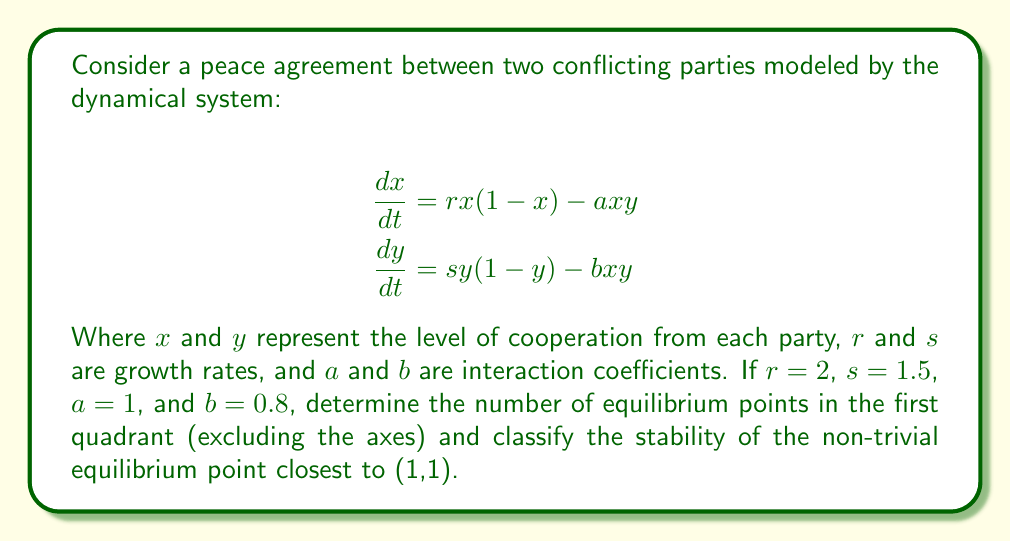Teach me how to tackle this problem. To solve this problem, we'll follow these steps:

1) Find the equilibrium points by setting $\frac{dx}{dt} = 0$ and $\frac{dy}{dt} = 0$:

   $$2x(1-x) - xy = 0$$
   $$1.5y(1-y) - 0.8xy = 0$$

2) Solve these equations:
   From the first equation:
   $$x(2-2x-y) = 0$$
   So either $x=0$ or $2-2x-y=0$

   From the second equation:
   $$y(1.5-1.5y-0.8x) = 0$$
   So either $y=0$ or $1.5-1.5y-0.8x=0$

3) The equilibrium points are:
   (0,0), (1,0), (0,1), and the intersection of $2-2x-y=0$ and $1.5-1.5y-0.8x=0$

4) To find the non-trivial equilibrium, solve:
   $$2-2x-y=0$$
   $$1.5-1.5y-0.8x=0$$

   Substituting $y=2-2x$ into the second equation:
   $$1.5-1.5(2-2x)-0.8x=0$$
   $$1.5-3+3x-0.8x=0$$
   $$2.2x=1.5$$
   $$x=\frac{15}{22}$$

   Then $y=2-2(\frac{15}{22})=\frac{16}{22}$

5) So the non-trivial equilibrium point is $(\frac{15}{22},\frac{16}{22})$

6) To classify stability, we need to find the Jacobian matrix at this point:

   $$J = \begin{bmatrix} 
   2-4x-y & -x \\
   -0.8y & 1.5-3y-0.8x
   \end{bmatrix}$$

   At $(\frac{15}{22},\frac{16}{22})$:

   $$J = \begin{bmatrix} 
   2-\frac{60}{22}-\frac{16}{22} & -\frac{15}{22} \\
   -0.8(\frac{16}{22}) & 1.5-3(\frac{16}{22})-0.8(\frac{15}{22})
   \end{bmatrix}$$

   $$= \begin{bmatrix} 
   -\frac{30}{22} & -\frac{15}{22} \\
   -\frac{64}{110} & -\frac{30}{22}
   \end{bmatrix}$$

7) The eigenvalues of this matrix are both negative real numbers, indicating that this equilibrium point is a stable node.
Answer: 3 equilibrium points in first quadrant; stable node at $(\frac{15}{22},\frac{16}{22})$ 